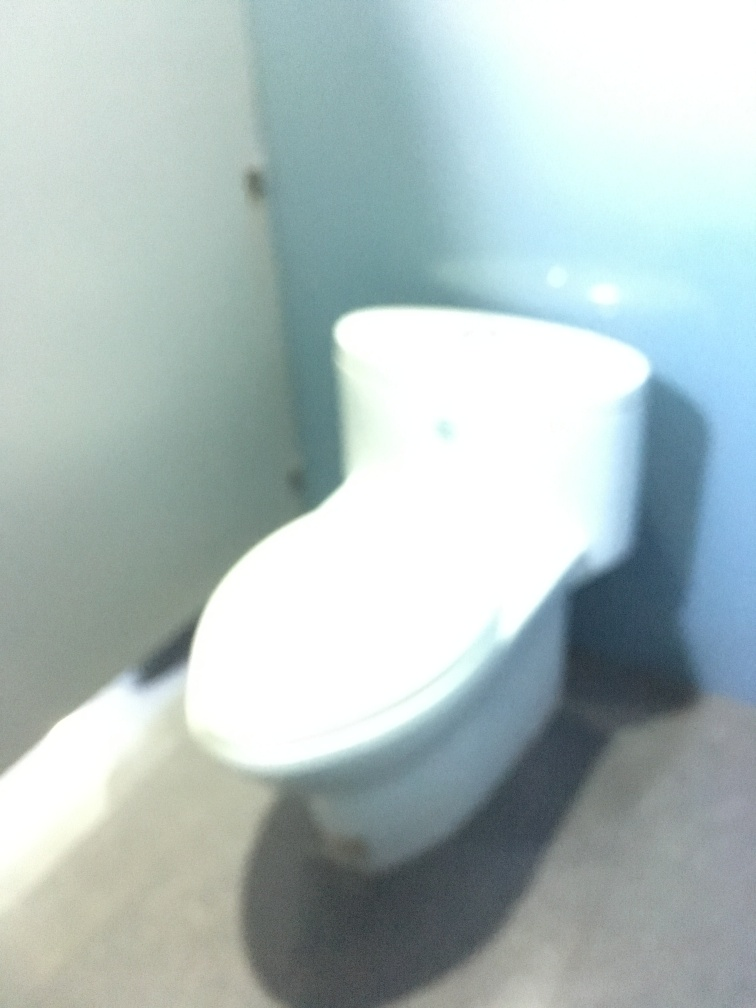Despite the blur, can we identify any objects in this photo? Even though the photo is blurry, we can identify the main object as a toilet. Its distinctive shape, with the bowl and seat, is recognizable, though details like color, material, and specific design are impossible to determine accurately due to the lack of focus. Considering the object in the image appears to be a toilet, can you suggest tips for improving a similar photograph? Certainly! For a better photograph, ensure the camera is steady—use a tripod if available. Utilize good lighting to prevent shadows and enhance clarity. Adjust the focus correctly by either using automatic focus with a point selected on the object or manual focus if you're experienced. Lastly, leave some space between the camera and the object to avoid needing special macro settings unless that's the desired effect. 